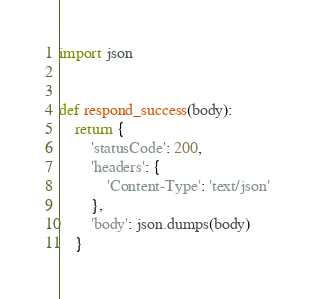<code> <loc_0><loc_0><loc_500><loc_500><_Python_>import json


def respond_success(body):
    return {
        'statusCode': 200,
        'headers': {
            'Content-Type': 'text/json'
        },
        'body': json.dumps(body)
    }
</code> 